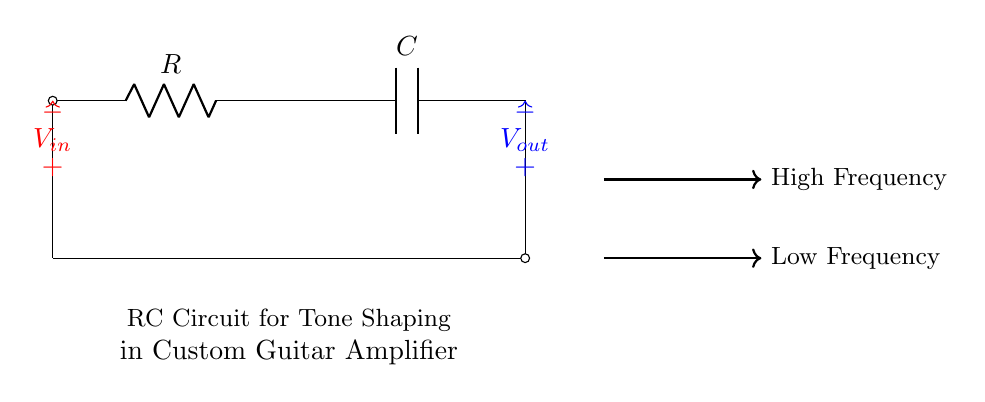What type of circuit is this? This is an RC circuit, which consists of a resistor (R) and a capacitor (C) connected in series. The circuit is specifically designed for tone shaping in a custom guitar amplifier, as indicated by the label.
Answer: RC circuit What components are in the circuit? The circuit contains two components: a resistor denoted as R and a capacitor denoted as C. These components are arranged in series.
Answer: Resistor and capacitor What is the output voltage in relation to the input voltage? The output voltage is derived from the input voltage passing through the RC combination. The relationship depends on the frequency of the input signal and the values of R and C.
Answer: Frequency-dependent What happens to high-frequency signals in this circuit? High-frequency signals tend to be attenuated in an RC circuit like this one, as the capacitor will charge quickly and block them from passing through to the output.
Answer: Attenuated How does this circuit affect low-frequency signals? Low-frequency signals are allowed to pass through to the output with less attenuation, as the capacitor will charge slowly, allowing them to reach the output voltage.
Answer: Passed through What does the arrow direction indicate for the voltages? The arrows indicate the direction of current flow; the voltage sources at the input and output suggest how the circuit processes signals. The input voltage enters the circuit, while the output voltage comes from the output terminal.
Answer: Current direction 